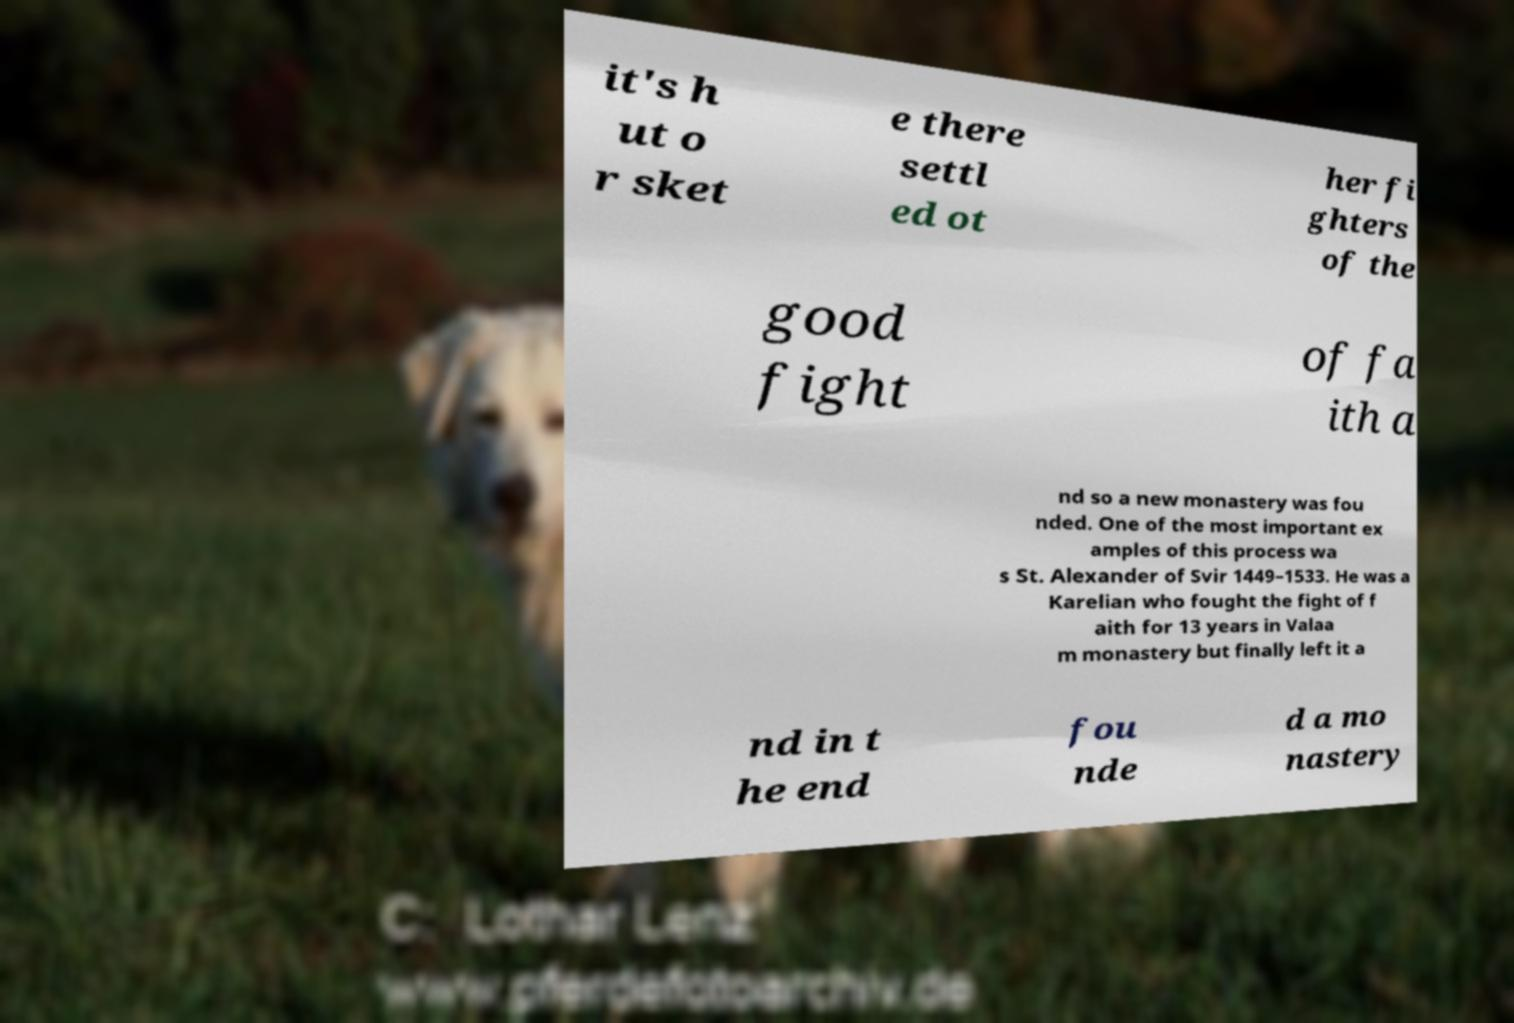Could you assist in decoding the text presented in this image and type it out clearly? it's h ut o r sket e there settl ed ot her fi ghters of the good fight of fa ith a nd so a new monastery was fou nded. One of the most important ex amples of this process wa s St. Alexander of Svir 1449–1533. He was a Karelian who fought the fight of f aith for 13 years in Valaa m monastery but finally left it a nd in t he end fou nde d a mo nastery 